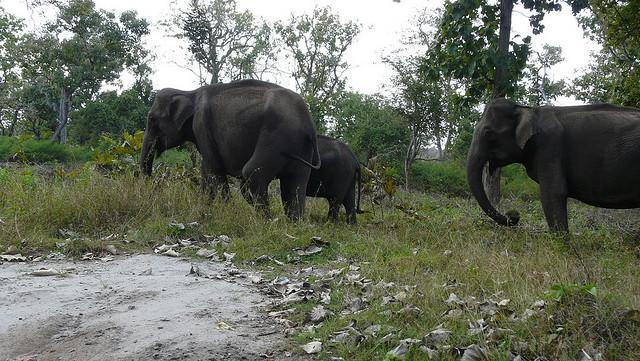How many elephants are there?
Give a very brief answer. 3. How many bananas are in the bundle?
Give a very brief answer. 0. How many baby elephants are there?
Give a very brief answer. 1. How many animals are shown?
Give a very brief answer. 3. How many elephants are visible?
Give a very brief answer. 3. How many men are smiling with teeth showing?
Give a very brief answer. 0. 